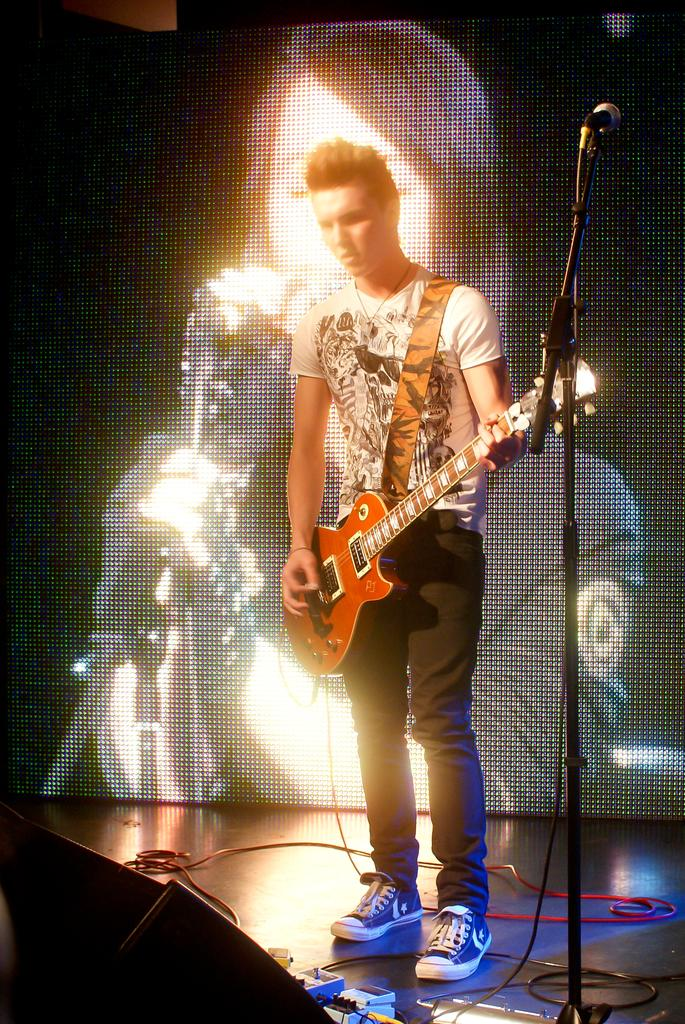What is the man in the image doing? The man is playing a guitar. What object is the man positioned in front of? The man is in front of a microphone. What can be seen in the background of the image? There is a projector screen and cables visible in the background. What type of spade is the man using to dig in the image? There is no spade present in the image; the man is playing a guitar and standing in front of a microphone. How many horses are visible in the image? There are no horses present in the image; the focus is on the man playing a guitar and the microphone. 